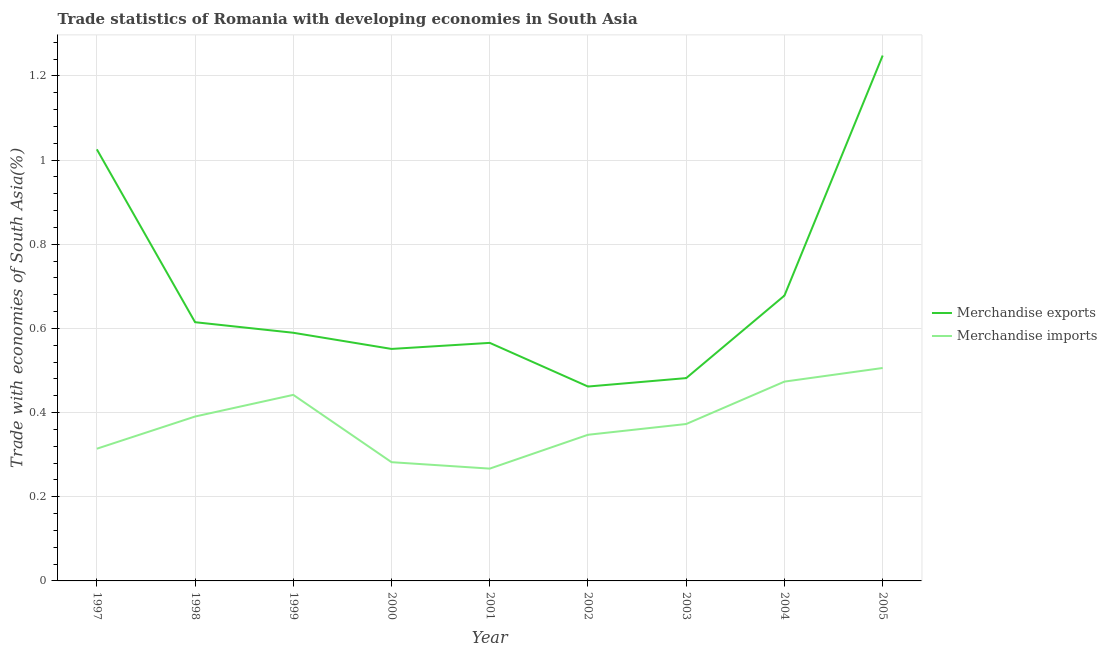Is the number of lines equal to the number of legend labels?
Your answer should be compact. Yes. What is the merchandise exports in 2005?
Make the answer very short. 1.25. Across all years, what is the maximum merchandise exports?
Offer a very short reply. 1.25. Across all years, what is the minimum merchandise imports?
Your answer should be very brief. 0.27. In which year was the merchandise imports maximum?
Keep it short and to the point. 2005. What is the total merchandise exports in the graph?
Provide a succinct answer. 6.22. What is the difference between the merchandise exports in 2000 and that in 2001?
Give a very brief answer. -0.01. What is the difference between the merchandise imports in 1998 and the merchandise exports in 2000?
Keep it short and to the point. -0.16. What is the average merchandise exports per year?
Your response must be concise. 0.69. In the year 2002, what is the difference between the merchandise imports and merchandise exports?
Keep it short and to the point. -0.11. What is the ratio of the merchandise imports in 1998 to that in 2005?
Make the answer very short. 0.77. Is the merchandise exports in 1997 less than that in 1999?
Keep it short and to the point. No. Is the difference between the merchandise exports in 1997 and 2000 greater than the difference between the merchandise imports in 1997 and 2000?
Offer a very short reply. Yes. What is the difference between the highest and the second highest merchandise exports?
Provide a short and direct response. 0.22. What is the difference between the highest and the lowest merchandise exports?
Keep it short and to the point. 0.79. In how many years, is the merchandise imports greater than the average merchandise imports taken over all years?
Your answer should be compact. 4. Is the merchandise imports strictly greater than the merchandise exports over the years?
Offer a terse response. No. How many lines are there?
Make the answer very short. 2. How many years are there in the graph?
Offer a terse response. 9. What is the title of the graph?
Provide a succinct answer. Trade statistics of Romania with developing economies in South Asia. What is the label or title of the Y-axis?
Ensure brevity in your answer.  Trade with economies of South Asia(%). What is the Trade with economies of South Asia(%) of Merchandise exports in 1997?
Give a very brief answer. 1.03. What is the Trade with economies of South Asia(%) in Merchandise imports in 1997?
Offer a very short reply. 0.31. What is the Trade with economies of South Asia(%) of Merchandise exports in 1998?
Give a very brief answer. 0.61. What is the Trade with economies of South Asia(%) of Merchandise imports in 1998?
Provide a short and direct response. 0.39. What is the Trade with economies of South Asia(%) of Merchandise exports in 1999?
Your answer should be compact. 0.59. What is the Trade with economies of South Asia(%) in Merchandise imports in 1999?
Offer a terse response. 0.44. What is the Trade with economies of South Asia(%) of Merchandise exports in 2000?
Your response must be concise. 0.55. What is the Trade with economies of South Asia(%) of Merchandise imports in 2000?
Your answer should be very brief. 0.28. What is the Trade with economies of South Asia(%) of Merchandise exports in 2001?
Make the answer very short. 0.57. What is the Trade with economies of South Asia(%) in Merchandise imports in 2001?
Ensure brevity in your answer.  0.27. What is the Trade with economies of South Asia(%) in Merchandise exports in 2002?
Offer a very short reply. 0.46. What is the Trade with economies of South Asia(%) in Merchandise imports in 2002?
Give a very brief answer. 0.35. What is the Trade with economies of South Asia(%) in Merchandise exports in 2003?
Offer a terse response. 0.48. What is the Trade with economies of South Asia(%) of Merchandise imports in 2003?
Offer a very short reply. 0.37. What is the Trade with economies of South Asia(%) in Merchandise exports in 2004?
Give a very brief answer. 0.68. What is the Trade with economies of South Asia(%) in Merchandise imports in 2004?
Keep it short and to the point. 0.47. What is the Trade with economies of South Asia(%) in Merchandise exports in 2005?
Keep it short and to the point. 1.25. What is the Trade with economies of South Asia(%) in Merchandise imports in 2005?
Provide a short and direct response. 0.51. Across all years, what is the maximum Trade with economies of South Asia(%) of Merchandise exports?
Your answer should be compact. 1.25. Across all years, what is the maximum Trade with economies of South Asia(%) of Merchandise imports?
Your answer should be very brief. 0.51. Across all years, what is the minimum Trade with economies of South Asia(%) of Merchandise exports?
Your answer should be very brief. 0.46. Across all years, what is the minimum Trade with economies of South Asia(%) of Merchandise imports?
Provide a short and direct response. 0.27. What is the total Trade with economies of South Asia(%) in Merchandise exports in the graph?
Provide a succinct answer. 6.22. What is the total Trade with economies of South Asia(%) in Merchandise imports in the graph?
Your answer should be very brief. 3.4. What is the difference between the Trade with economies of South Asia(%) of Merchandise exports in 1997 and that in 1998?
Provide a succinct answer. 0.41. What is the difference between the Trade with economies of South Asia(%) in Merchandise imports in 1997 and that in 1998?
Offer a very short reply. -0.08. What is the difference between the Trade with economies of South Asia(%) of Merchandise exports in 1997 and that in 1999?
Your response must be concise. 0.44. What is the difference between the Trade with economies of South Asia(%) of Merchandise imports in 1997 and that in 1999?
Offer a very short reply. -0.13. What is the difference between the Trade with economies of South Asia(%) in Merchandise exports in 1997 and that in 2000?
Provide a short and direct response. 0.47. What is the difference between the Trade with economies of South Asia(%) of Merchandise imports in 1997 and that in 2000?
Give a very brief answer. 0.03. What is the difference between the Trade with economies of South Asia(%) of Merchandise exports in 1997 and that in 2001?
Provide a succinct answer. 0.46. What is the difference between the Trade with economies of South Asia(%) in Merchandise imports in 1997 and that in 2001?
Give a very brief answer. 0.05. What is the difference between the Trade with economies of South Asia(%) of Merchandise exports in 1997 and that in 2002?
Give a very brief answer. 0.56. What is the difference between the Trade with economies of South Asia(%) of Merchandise imports in 1997 and that in 2002?
Give a very brief answer. -0.03. What is the difference between the Trade with economies of South Asia(%) of Merchandise exports in 1997 and that in 2003?
Your answer should be very brief. 0.54. What is the difference between the Trade with economies of South Asia(%) of Merchandise imports in 1997 and that in 2003?
Offer a very short reply. -0.06. What is the difference between the Trade with economies of South Asia(%) in Merchandise exports in 1997 and that in 2004?
Offer a terse response. 0.35. What is the difference between the Trade with economies of South Asia(%) in Merchandise imports in 1997 and that in 2004?
Offer a terse response. -0.16. What is the difference between the Trade with economies of South Asia(%) of Merchandise exports in 1997 and that in 2005?
Your answer should be compact. -0.22. What is the difference between the Trade with economies of South Asia(%) of Merchandise imports in 1997 and that in 2005?
Keep it short and to the point. -0.19. What is the difference between the Trade with economies of South Asia(%) in Merchandise exports in 1998 and that in 1999?
Keep it short and to the point. 0.03. What is the difference between the Trade with economies of South Asia(%) of Merchandise imports in 1998 and that in 1999?
Provide a succinct answer. -0.05. What is the difference between the Trade with economies of South Asia(%) of Merchandise exports in 1998 and that in 2000?
Your response must be concise. 0.06. What is the difference between the Trade with economies of South Asia(%) of Merchandise imports in 1998 and that in 2000?
Provide a short and direct response. 0.11. What is the difference between the Trade with economies of South Asia(%) of Merchandise exports in 1998 and that in 2001?
Offer a very short reply. 0.05. What is the difference between the Trade with economies of South Asia(%) of Merchandise imports in 1998 and that in 2001?
Provide a short and direct response. 0.12. What is the difference between the Trade with economies of South Asia(%) in Merchandise exports in 1998 and that in 2002?
Your response must be concise. 0.15. What is the difference between the Trade with economies of South Asia(%) in Merchandise imports in 1998 and that in 2002?
Provide a short and direct response. 0.04. What is the difference between the Trade with economies of South Asia(%) in Merchandise exports in 1998 and that in 2003?
Provide a succinct answer. 0.13. What is the difference between the Trade with economies of South Asia(%) of Merchandise imports in 1998 and that in 2003?
Keep it short and to the point. 0.02. What is the difference between the Trade with economies of South Asia(%) of Merchandise exports in 1998 and that in 2004?
Give a very brief answer. -0.06. What is the difference between the Trade with economies of South Asia(%) in Merchandise imports in 1998 and that in 2004?
Give a very brief answer. -0.08. What is the difference between the Trade with economies of South Asia(%) of Merchandise exports in 1998 and that in 2005?
Your response must be concise. -0.63. What is the difference between the Trade with economies of South Asia(%) in Merchandise imports in 1998 and that in 2005?
Keep it short and to the point. -0.12. What is the difference between the Trade with economies of South Asia(%) of Merchandise exports in 1999 and that in 2000?
Provide a succinct answer. 0.04. What is the difference between the Trade with economies of South Asia(%) of Merchandise imports in 1999 and that in 2000?
Provide a short and direct response. 0.16. What is the difference between the Trade with economies of South Asia(%) in Merchandise exports in 1999 and that in 2001?
Give a very brief answer. 0.02. What is the difference between the Trade with economies of South Asia(%) in Merchandise imports in 1999 and that in 2001?
Make the answer very short. 0.18. What is the difference between the Trade with economies of South Asia(%) of Merchandise exports in 1999 and that in 2002?
Your answer should be compact. 0.13. What is the difference between the Trade with economies of South Asia(%) in Merchandise imports in 1999 and that in 2002?
Your answer should be very brief. 0.09. What is the difference between the Trade with economies of South Asia(%) of Merchandise exports in 1999 and that in 2003?
Ensure brevity in your answer.  0.11. What is the difference between the Trade with economies of South Asia(%) in Merchandise imports in 1999 and that in 2003?
Give a very brief answer. 0.07. What is the difference between the Trade with economies of South Asia(%) of Merchandise exports in 1999 and that in 2004?
Your answer should be compact. -0.09. What is the difference between the Trade with economies of South Asia(%) of Merchandise imports in 1999 and that in 2004?
Make the answer very short. -0.03. What is the difference between the Trade with economies of South Asia(%) in Merchandise exports in 1999 and that in 2005?
Offer a terse response. -0.66. What is the difference between the Trade with economies of South Asia(%) of Merchandise imports in 1999 and that in 2005?
Ensure brevity in your answer.  -0.06. What is the difference between the Trade with economies of South Asia(%) in Merchandise exports in 2000 and that in 2001?
Provide a succinct answer. -0.01. What is the difference between the Trade with economies of South Asia(%) in Merchandise imports in 2000 and that in 2001?
Make the answer very short. 0.02. What is the difference between the Trade with economies of South Asia(%) of Merchandise exports in 2000 and that in 2002?
Your answer should be very brief. 0.09. What is the difference between the Trade with economies of South Asia(%) of Merchandise imports in 2000 and that in 2002?
Provide a succinct answer. -0.07. What is the difference between the Trade with economies of South Asia(%) in Merchandise exports in 2000 and that in 2003?
Offer a very short reply. 0.07. What is the difference between the Trade with economies of South Asia(%) in Merchandise imports in 2000 and that in 2003?
Provide a short and direct response. -0.09. What is the difference between the Trade with economies of South Asia(%) of Merchandise exports in 2000 and that in 2004?
Keep it short and to the point. -0.13. What is the difference between the Trade with economies of South Asia(%) of Merchandise imports in 2000 and that in 2004?
Keep it short and to the point. -0.19. What is the difference between the Trade with economies of South Asia(%) in Merchandise exports in 2000 and that in 2005?
Keep it short and to the point. -0.7. What is the difference between the Trade with economies of South Asia(%) of Merchandise imports in 2000 and that in 2005?
Offer a very short reply. -0.22. What is the difference between the Trade with economies of South Asia(%) of Merchandise exports in 2001 and that in 2002?
Ensure brevity in your answer.  0.1. What is the difference between the Trade with economies of South Asia(%) of Merchandise imports in 2001 and that in 2002?
Your answer should be very brief. -0.08. What is the difference between the Trade with economies of South Asia(%) in Merchandise exports in 2001 and that in 2003?
Make the answer very short. 0.08. What is the difference between the Trade with economies of South Asia(%) of Merchandise imports in 2001 and that in 2003?
Your response must be concise. -0.11. What is the difference between the Trade with economies of South Asia(%) in Merchandise exports in 2001 and that in 2004?
Make the answer very short. -0.11. What is the difference between the Trade with economies of South Asia(%) of Merchandise imports in 2001 and that in 2004?
Keep it short and to the point. -0.21. What is the difference between the Trade with economies of South Asia(%) of Merchandise exports in 2001 and that in 2005?
Make the answer very short. -0.68. What is the difference between the Trade with economies of South Asia(%) of Merchandise imports in 2001 and that in 2005?
Your response must be concise. -0.24. What is the difference between the Trade with economies of South Asia(%) in Merchandise exports in 2002 and that in 2003?
Your answer should be very brief. -0.02. What is the difference between the Trade with economies of South Asia(%) of Merchandise imports in 2002 and that in 2003?
Your answer should be compact. -0.03. What is the difference between the Trade with economies of South Asia(%) of Merchandise exports in 2002 and that in 2004?
Keep it short and to the point. -0.22. What is the difference between the Trade with economies of South Asia(%) in Merchandise imports in 2002 and that in 2004?
Your response must be concise. -0.13. What is the difference between the Trade with economies of South Asia(%) in Merchandise exports in 2002 and that in 2005?
Provide a short and direct response. -0.79. What is the difference between the Trade with economies of South Asia(%) in Merchandise imports in 2002 and that in 2005?
Give a very brief answer. -0.16. What is the difference between the Trade with economies of South Asia(%) in Merchandise exports in 2003 and that in 2004?
Offer a very short reply. -0.2. What is the difference between the Trade with economies of South Asia(%) of Merchandise imports in 2003 and that in 2004?
Provide a succinct answer. -0.1. What is the difference between the Trade with economies of South Asia(%) of Merchandise exports in 2003 and that in 2005?
Provide a short and direct response. -0.77. What is the difference between the Trade with economies of South Asia(%) of Merchandise imports in 2003 and that in 2005?
Offer a terse response. -0.13. What is the difference between the Trade with economies of South Asia(%) in Merchandise exports in 2004 and that in 2005?
Keep it short and to the point. -0.57. What is the difference between the Trade with economies of South Asia(%) of Merchandise imports in 2004 and that in 2005?
Keep it short and to the point. -0.03. What is the difference between the Trade with economies of South Asia(%) of Merchandise exports in 1997 and the Trade with economies of South Asia(%) of Merchandise imports in 1998?
Offer a terse response. 0.63. What is the difference between the Trade with economies of South Asia(%) in Merchandise exports in 1997 and the Trade with economies of South Asia(%) in Merchandise imports in 1999?
Ensure brevity in your answer.  0.58. What is the difference between the Trade with economies of South Asia(%) in Merchandise exports in 1997 and the Trade with economies of South Asia(%) in Merchandise imports in 2000?
Offer a terse response. 0.74. What is the difference between the Trade with economies of South Asia(%) of Merchandise exports in 1997 and the Trade with economies of South Asia(%) of Merchandise imports in 2001?
Offer a terse response. 0.76. What is the difference between the Trade with economies of South Asia(%) in Merchandise exports in 1997 and the Trade with economies of South Asia(%) in Merchandise imports in 2002?
Your response must be concise. 0.68. What is the difference between the Trade with economies of South Asia(%) of Merchandise exports in 1997 and the Trade with economies of South Asia(%) of Merchandise imports in 2003?
Give a very brief answer. 0.65. What is the difference between the Trade with economies of South Asia(%) of Merchandise exports in 1997 and the Trade with economies of South Asia(%) of Merchandise imports in 2004?
Keep it short and to the point. 0.55. What is the difference between the Trade with economies of South Asia(%) in Merchandise exports in 1997 and the Trade with economies of South Asia(%) in Merchandise imports in 2005?
Keep it short and to the point. 0.52. What is the difference between the Trade with economies of South Asia(%) in Merchandise exports in 1998 and the Trade with economies of South Asia(%) in Merchandise imports in 1999?
Make the answer very short. 0.17. What is the difference between the Trade with economies of South Asia(%) of Merchandise exports in 1998 and the Trade with economies of South Asia(%) of Merchandise imports in 2000?
Your answer should be compact. 0.33. What is the difference between the Trade with economies of South Asia(%) of Merchandise exports in 1998 and the Trade with economies of South Asia(%) of Merchandise imports in 2001?
Provide a succinct answer. 0.35. What is the difference between the Trade with economies of South Asia(%) in Merchandise exports in 1998 and the Trade with economies of South Asia(%) in Merchandise imports in 2002?
Your answer should be compact. 0.27. What is the difference between the Trade with economies of South Asia(%) in Merchandise exports in 1998 and the Trade with economies of South Asia(%) in Merchandise imports in 2003?
Make the answer very short. 0.24. What is the difference between the Trade with economies of South Asia(%) of Merchandise exports in 1998 and the Trade with economies of South Asia(%) of Merchandise imports in 2004?
Provide a short and direct response. 0.14. What is the difference between the Trade with economies of South Asia(%) of Merchandise exports in 1998 and the Trade with economies of South Asia(%) of Merchandise imports in 2005?
Provide a short and direct response. 0.11. What is the difference between the Trade with economies of South Asia(%) of Merchandise exports in 1999 and the Trade with economies of South Asia(%) of Merchandise imports in 2000?
Provide a succinct answer. 0.31. What is the difference between the Trade with economies of South Asia(%) of Merchandise exports in 1999 and the Trade with economies of South Asia(%) of Merchandise imports in 2001?
Provide a succinct answer. 0.32. What is the difference between the Trade with economies of South Asia(%) of Merchandise exports in 1999 and the Trade with economies of South Asia(%) of Merchandise imports in 2002?
Give a very brief answer. 0.24. What is the difference between the Trade with economies of South Asia(%) of Merchandise exports in 1999 and the Trade with economies of South Asia(%) of Merchandise imports in 2003?
Provide a short and direct response. 0.22. What is the difference between the Trade with economies of South Asia(%) of Merchandise exports in 1999 and the Trade with economies of South Asia(%) of Merchandise imports in 2004?
Give a very brief answer. 0.12. What is the difference between the Trade with economies of South Asia(%) of Merchandise exports in 1999 and the Trade with economies of South Asia(%) of Merchandise imports in 2005?
Provide a succinct answer. 0.08. What is the difference between the Trade with economies of South Asia(%) in Merchandise exports in 2000 and the Trade with economies of South Asia(%) in Merchandise imports in 2001?
Offer a very short reply. 0.28. What is the difference between the Trade with economies of South Asia(%) in Merchandise exports in 2000 and the Trade with economies of South Asia(%) in Merchandise imports in 2002?
Ensure brevity in your answer.  0.2. What is the difference between the Trade with economies of South Asia(%) in Merchandise exports in 2000 and the Trade with economies of South Asia(%) in Merchandise imports in 2003?
Keep it short and to the point. 0.18. What is the difference between the Trade with economies of South Asia(%) in Merchandise exports in 2000 and the Trade with economies of South Asia(%) in Merchandise imports in 2004?
Provide a short and direct response. 0.08. What is the difference between the Trade with economies of South Asia(%) of Merchandise exports in 2000 and the Trade with economies of South Asia(%) of Merchandise imports in 2005?
Make the answer very short. 0.05. What is the difference between the Trade with economies of South Asia(%) of Merchandise exports in 2001 and the Trade with economies of South Asia(%) of Merchandise imports in 2002?
Offer a terse response. 0.22. What is the difference between the Trade with economies of South Asia(%) of Merchandise exports in 2001 and the Trade with economies of South Asia(%) of Merchandise imports in 2003?
Offer a very short reply. 0.19. What is the difference between the Trade with economies of South Asia(%) in Merchandise exports in 2001 and the Trade with economies of South Asia(%) in Merchandise imports in 2004?
Make the answer very short. 0.09. What is the difference between the Trade with economies of South Asia(%) of Merchandise exports in 2001 and the Trade with economies of South Asia(%) of Merchandise imports in 2005?
Ensure brevity in your answer.  0.06. What is the difference between the Trade with economies of South Asia(%) of Merchandise exports in 2002 and the Trade with economies of South Asia(%) of Merchandise imports in 2003?
Your answer should be compact. 0.09. What is the difference between the Trade with economies of South Asia(%) in Merchandise exports in 2002 and the Trade with economies of South Asia(%) in Merchandise imports in 2004?
Your answer should be very brief. -0.01. What is the difference between the Trade with economies of South Asia(%) in Merchandise exports in 2002 and the Trade with economies of South Asia(%) in Merchandise imports in 2005?
Your response must be concise. -0.04. What is the difference between the Trade with economies of South Asia(%) in Merchandise exports in 2003 and the Trade with economies of South Asia(%) in Merchandise imports in 2004?
Provide a short and direct response. 0.01. What is the difference between the Trade with economies of South Asia(%) of Merchandise exports in 2003 and the Trade with economies of South Asia(%) of Merchandise imports in 2005?
Make the answer very short. -0.02. What is the difference between the Trade with economies of South Asia(%) in Merchandise exports in 2004 and the Trade with economies of South Asia(%) in Merchandise imports in 2005?
Offer a very short reply. 0.17. What is the average Trade with economies of South Asia(%) in Merchandise exports per year?
Your response must be concise. 0.69. What is the average Trade with economies of South Asia(%) in Merchandise imports per year?
Ensure brevity in your answer.  0.38. In the year 1997, what is the difference between the Trade with economies of South Asia(%) in Merchandise exports and Trade with economies of South Asia(%) in Merchandise imports?
Offer a very short reply. 0.71. In the year 1998, what is the difference between the Trade with economies of South Asia(%) of Merchandise exports and Trade with economies of South Asia(%) of Merchandise imports?
Ensure brevity in your answer.  0.22. In the year 1999, what is the difference between the Trade with economies of South Asia(%) of Merchandise exports and Trade with economies of South Asia(%) of Merchandise imports?
Your answer should be compact. 0.15. In the year 2000, what is the difference between the Trade with economies of South Asia(%) of Merchandise exports and Trade with economies of South Asia(%) of Merchandise imports?
Make the answer very short. 0.27. In the year 2001, what is the difference between the Trade with economies of South Asia(%) in Merchandise exports and Trade with economies of South Asia(%) in Merchandise imports?
Offer a very short reply. 0.3. In the year 2002, what is the difference between the Trade with economies of South Asia(%) of Merchandise exports and Trade with economies of South Asia(%) of Merchandise imports?
Provide a short and direct response. 0.11. In the year 2003, what is the difference between the Trade with economies of South Asia(%) in Merchandise exports and Trade with economies of South Asia(%) in Merchandise imports?
Provide a succinct answer. 0.11. In the year 2004, what is the difference between the Trade with economies of South Asia(%) of Merchandise exports and Trade with economies of South Asia(%) of Merchandise imports?
Offer a terse response. 0.2. In the year 2005, what is the difference between the Trade with economies of South Asia(%) in Merchandise exports and Trade with economies of South Asia(%) in Merchandise imports?
Ensure brevity in your answer.  0.74. What is the ratio of the Trade with economies of South Asia(%) of Merchandise exports in 1997 to that in 1998?
Ensure brevity in your answer.  1.67. What is the ratio of the Trade with economies of South Asia(%) in Merchandise imports in 1997 to that in 1998?
Keep it short and to the point. 0.8. What is the ratio of the Trade with economies of South Asia(%) in Merchandise exports in 1997 to that in 1999?
Offer a very short reply. 1.74. What is the ratio of the Trade with economies of South Asia(%) in Merchandise imports in 1997 to that in 1999?
Provide a succinct answer. 0.71. What is the ratio of the Trade with economies of South Asia(%) in Merchandise exports in 1997 to that in 2000?
Keep it short and to the point. 1.86. What is the ratio of the Trade with economies of South Asia(%) in Merchandise imports in 1997 to that in 2000?
Give a very brief answer. 1.11. What is the ratio of the Trade with economies of South Asia(%) of Merchandise exports in 1997 to that in 2001?
Your answer should be compact. 1.81. What is the ratio of the Trade with economies of South Asia(%) in Merchandise imports in 1997 to that in 2001?
Your response must be concise. 1.18. What is the ratio of the Trade with economies of South Asia(%) in Merchandise exports in 1997 to that in 2002?
Your answer should be very brief. 2.22. What is the ratio of the Trade with economies of South Asia(%) in Merchandise imports in 1997 to that in 2002?
Offer a very short reply. 0.9. What is the ratio of the Trade with economies of South Asia(%) of Merchandise exports in 1997 to that in 2003?
Your answer should be compact. 2.13. What is the ratio of the Trade with economies of South Asia(%) of Merchandise imports in 1997 to that in 2003?
Your response must be concise. 0.84. What is the ratio of the Trade with economies of South Asia(%) in Merchandise exports in 1997 to that in 2004?
Offer a very short reply. 1.51. What is the ratio of the Trade with economies of South Asia(%) in Merchandise imports in 1997 to that in 2004?
Ensure brevity in your answer.  0.66. What is the ratio of the Trade with economies of South Asia(%) in Merchandise exports in 1997 to that in 2005?
Make the answer very short. 0.82. What is the ratio of the Trade with economies of South Asia(%) of Merchandise imports in 1997 to that in 2005?
Make the answer very short. 0.62. What is the ratio of the Trade with economies of South Asia(%) of Merchandise exports in 1998 to that in 1999?
Offer a very short reply. 1.04. What is the ratio of the Trade with economies of South Asia(%) in Merchandise imports in 1998 to that in 1999?
Your answer should be compact. 0.88. What is the ratio of the Trade with economies of South Asia(%) in Merchandise exports in 1998 to that in 2000?
Keep it short and to the point. 1.12. What is the ratio of the Trade with economies of South Asia(%) in Merchandise imports in 1998 to that in 2000?
Your answer should be very brief. 1.38. What is the ratio of the Trade with economies of South Asia(%) of Merchandise exports in 1998 to that in 2001?
Ensure brevity in your answer.  1.09. What is the ratio of the Trade with economies of South Asia(%) of Merchandise imports in 1998 to that in 2001?
Your answer should be compact. 1.46. What is the ratio of the Trade with economies of South Asia(%) of Merchandise exports in 1998 to that in 2002?
Your answer should be very brief. 1.33. What is the ratio of the Trade with economies of South Asia(%) of Merchandise imports in 1998 to that in 2002?
Provide a short and direct response. 1.12. What is the ratio of the Trade with economies of South Asia(%) of Merchandise exports in 1998 to that in 2003?
Offer a very short reply. 1.28. What is the ratio of the Trade with economies of South Asia(%) of Merchandise imports in 1998 to that in 2003?
Make the answer very short. 1.05. What is the ratio of the Trade with economies of South Asia(%) of Merchandise exports in 1998 to that in 2004?
Keep it short and to the point. 0.91. What is the ratio of the Trade with economies of South Asia(%) of Merchandise imports in 1998 to that in 2004?
Provide a succinct answer. 0.82. What is the ratio of the Trade with economies of South Asia(%) of Merchandise exports in 1998 to that in 2005?
Your response must be concise. 0.49. What is the ratio of the Trade with economies of South Asia(%) of Merchandise imports in 1998 to that in 2005?
Ensure brevity in your answer.  0.77. What is the ratio of the Trade with economies of South Asia(%) of Merchandise exports in 1999 to that in 2000?
Provide a short and direct response. 1.07. What is the ratio of the Trade with economies of South Asia(%) in Merchandise imports in 1999 to that in 2000?
Your answer should be very brief. 1.57. What is the ratio of the Trade with economies of South Asia(%) of Merchandise exports in 1999 to that in 2001?
Give a very brief answer. 1.04. What is the ratio of the Trade with economies of South Asia(%) in Merchandise imports in 1999 to that in 2001?
Your answer should be very brief. 1.66. What is the ratio of the Trade with economies of South Asia(%) of Merchandise exports in 1999 to that in 2002?
Offer a very short reply. 1.28. What is the ratio of the Trade with economies of South Asia(%) of Merchandise imports in 1999 to that in 2002?
Your answer should be compact. 1.27. What is the ratio of the Trade with economies of South Asia(%) of Merchandise exports in 1999 to that in 2003?
Give a very brief answer. 1.22. What is the ratio of the Trade with economies of South Asia(%) of Merchandise imports in 1999 to that in 2003?
Offer a terse response. 1.19. What is the ratio of the Trade with economies of South Asia(%) of Merchandise exports in 1999 to that in 2004?
Offer a very short reply. 0.87. What is the ratio of the Trade with economies of South Asia(%) in Merchandise imports in 1999 to that in 2004?
Give a very brief answer. 0.93. What is the ratio of the Trade with economies of South Asia(%) of Merchandise exports in 1999 to that in 2005?
Offer a very short reply. 0.47. What is the ratio of the Trade with economies of South Asia(%) in Merchandise imports in 1999 to that in 2005?
Provide a succinct answer. 0.87. What is the ratio of the Trade with economies of South Asia(%) of Merchandise exports in 2000 to that in 2001?
Provide a short and direct response. 0.97. What is the ratio of the Trade with economies of South Asia(%) of Merchandise imports in 2000 to that in 2001?
Your response must be concise. 1.06. What is the ratio of the Trade with economies of South Asia(%) of Merchandise exports in 2000 to that in 2002?
Make the answer very short. 1.19. What is the ratio of the Trade with economies of South Asia(%) of Merchandise imports in 2000 to that in 2002?
Offer a very short reply. 0.81. What is the ratio of the Trade with economies of South Asia(%) of Merchandise exports in 2000 to that in 2003?
Give a very brief answer. 1.14. What is the ratio of the Trade with economies of South Asia(%) of Merchandise imports in 2000 to that in 2003?
Provide a succinct answer. 0.76. What is the ratio of the Trade with economies of South Asia(%) in Merchandise exports in 2000 to that in 2004?
Your answer should be very brief. 0.81. What is the ratio of the Trade with economies of South Asia(%) of Merchandise imports in 2000 to that in 2004?
Offer a very short reply. 0.6. What is the ratio of the Trade with economies of South Asia(%) in Merchandise exports in 2000 to that in 2005?
Provide a succinct answer. 0.44. What is the ratio of the Trade with economies of South Asia(%) in Merchandise imports in 2000 to that in 2005?
Provide a short and direct response. 0.56. What is the ratio of the Trade with economies of South Asia(%) in Merchandise exports in 2001 to that in 2002?
Your answer should be compact. 1.22. What is the ratio of the Trade with economies of South Asia(%) in Merchandise imports in 2001 to that in 2002?
Provide a succinct answer. 0.77. What is the ratio of the Trade with economies of South Asia(%) in Merchandise exports in 2001 to that in 2003?
Make the answer very short. 1.17. What is the ratio of the Trade with economies of South Asia(%) in Merchandise imports in 2001 to that in 2003?
Your response must be concise. 0.72. What is the ratio of the Trade with economies of South Asia(%) of Merchandise exports in 2001 to that in 2004?
Provide a short and direct response. 0.83. What is the ratio of the Trade with economies of South Asia(%) of Merchandise imports in 2001 to that in 2004?
Keep it short and to the point. 0.56. What is the ratio of the Trade with economies of South Asia(%) of Merchandise exports in 2001 to that in 2005?
Your answer should be very brief. 0.45. What is the ratio of the Trade with economies of South Asia(%) in Merchandise imports in 2001 to that in 2005?
Your answer should be compact. 0.53. What is the ratio of the Trade with economies of South Asia(%) of Merchandise exports in 2002 to that in 2003?
Offer a very short reply. 0.96. What is the ratio of the Trade with economies of South Asia(%) of Merchandise imports in 2002 to that in 2003?
Keep it short and to the point. 0.93. What is the ratio of the Trade with economies of South Asia(%) in Merchandise exports in 2002 to that in 2004?
Offer a terse response. 0.68. What is the ratio of the Trade with economies of South Asia(%) of Merchandise imports in 2002 to that in 2004?
Your response must be concise. 0.73. What is the ratio of the Trade with economies of South Asia(%) in Merchandise exports in 2002 to that in 2005?
Your answer should be very brief. 0.37. What is the ratio of the Trade with economies of South Asia(%) in Merchandise imports in 2002 to that in 2005?
Your answer should be very brief. 0.69. What is the ratio of the Trade with economies of South Asia(%) in Merchandise exports in 2003 to that in 2004?
Provide a succinct answer. 0.71. What is the ratio of the Trade with economies of South Asia(%) of Merchandise imports in 2003 to that in 2004?
Provide a short and direct response. 0.79. What is the ratio of the Trade with economies of South Asia(%) in Merchandise exports in 2003 to that in 2005?
Your response must be concise. 0.39. What is the ratio of the Trade with economies of South Asia(%) of Merchandise imports in 2003 to that in 2005?
Provide a succinct answer. 0.74. What is the ratio of the Trade with economies of South Asia(%) of Merchandise exports in 2004 to that in 2005?
Give a very brief answer. 0.54. What is the ratio of the Trade with economies of South Asia(%) in Merchandise imports in 2004 to that in 2005?
Make the answer very short. 0.94. What is the difference between the highest and the second highest Trade with economies of South Asia(%) of Merchandise exports?
Your answer should be very brief. 0.22. What is the difference between the highest and the second highest Trade with economies of South Asia(%) in Merchandise imports?
Ensure brevity in your answer.  0.03. What is the difference between the highest and the lowest Trade with economies of South Asia(%) of Merchandise exports?
Keep it short and to the point. 0.79. What is the difference between the highest and the lowest Trade with economies of South Asia(%) in Merchandise imports?
Your response must be concise. 0.24. 